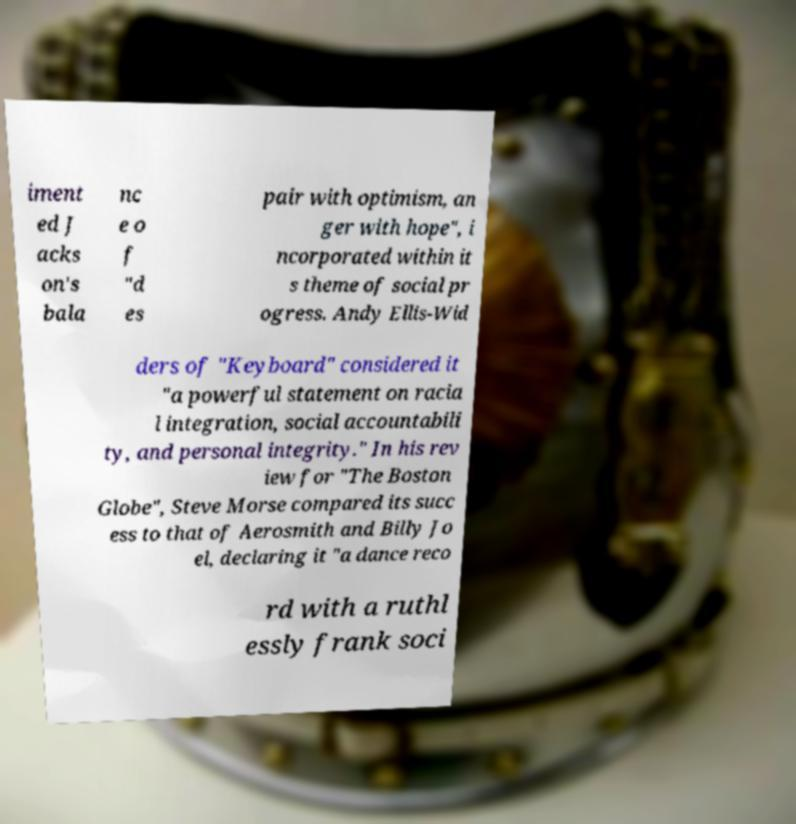Can you accurately transcribe the text from the provided image for me? iment ed J acks on's bala nc e o f "d es pair with optimism, an ger with hope", i ncorporated within it s theme of social pr ogress. Andy Ellis-Wid ders of "Keyboard" considered it "a powerful statement on racia l integration, social accountabili ty, and personal integrity." In his rev iew for "The Boston Globe", Steve Morse compared its succ ess to that of Aerosmith and Billy Jo el, declaring it "a dance reco rd with a ruthl essly frank soci 